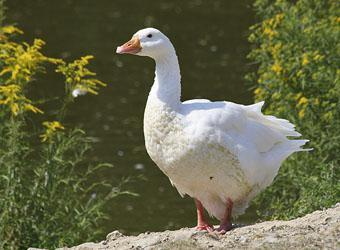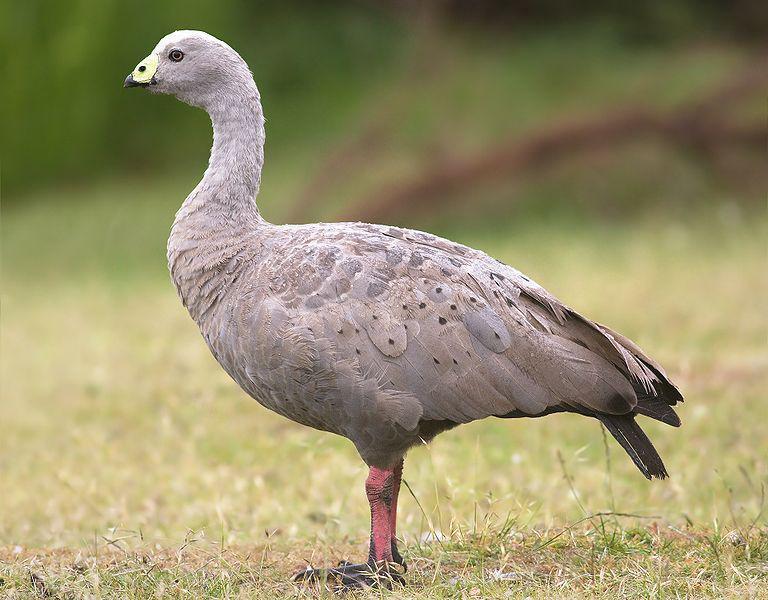The first image is the image on the left, the second image is the image on the right. Assess this claim about the two images: "There are two geese". Correct or not? Answer yes or no. Yes. 